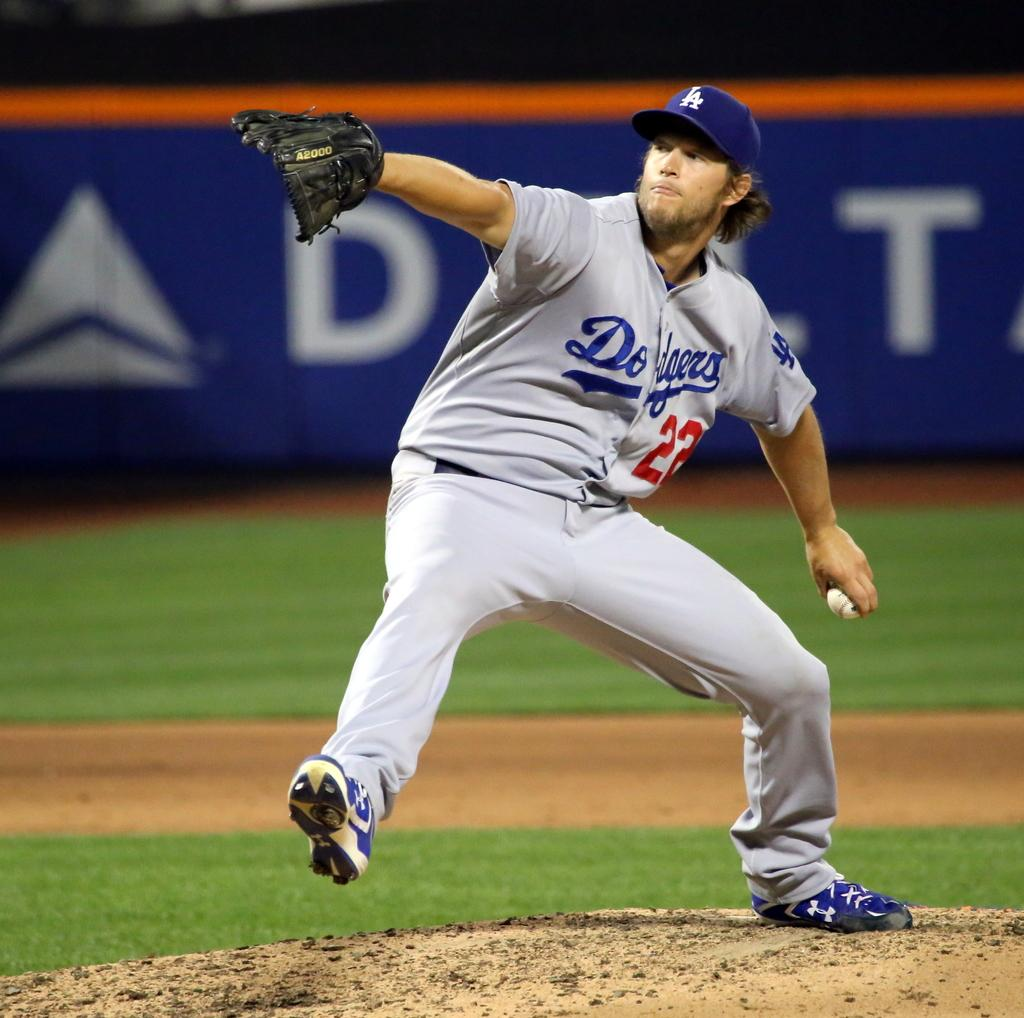<image>
Render a clear and concise summary of the photo. LA Dodgers number 22 with a mitt on the field sponsered by Delta 